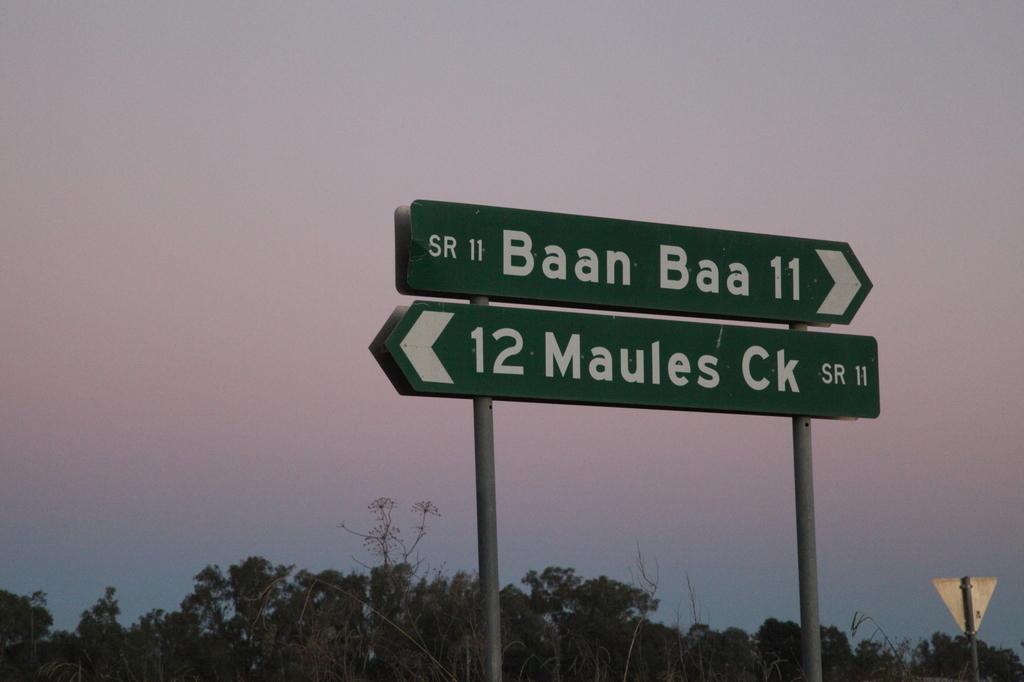How many distance units is it to baan baa?
Your answer should be compact. 11. What route is baan baa 11?
Offer a very short reply. Sr 11. 